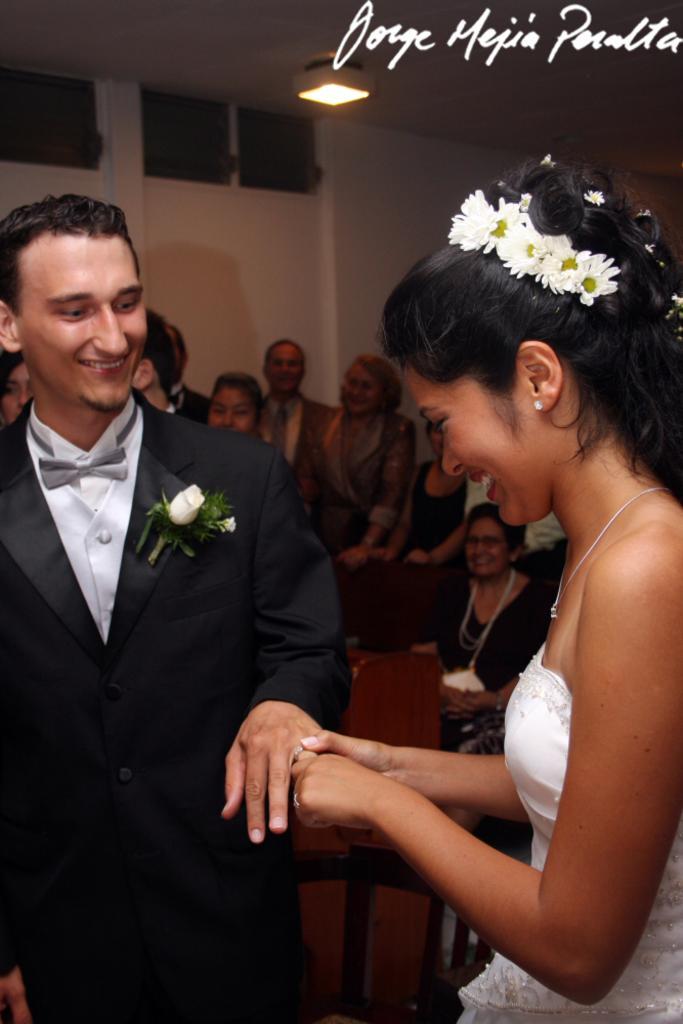In one or two sentences, can you explain what this image depicts? Here in this picture, in the front we can see a man and a woman standing on the floor, as we can see they are the bride and groom and the man is wearing a black colored suit and the woman is wearing white colored dress and both of them are smiling and the woman is placing the ring in the man's finger and behind them we can see other number of people standing and sitting over the place and at the top we can see a light present on the roof. 